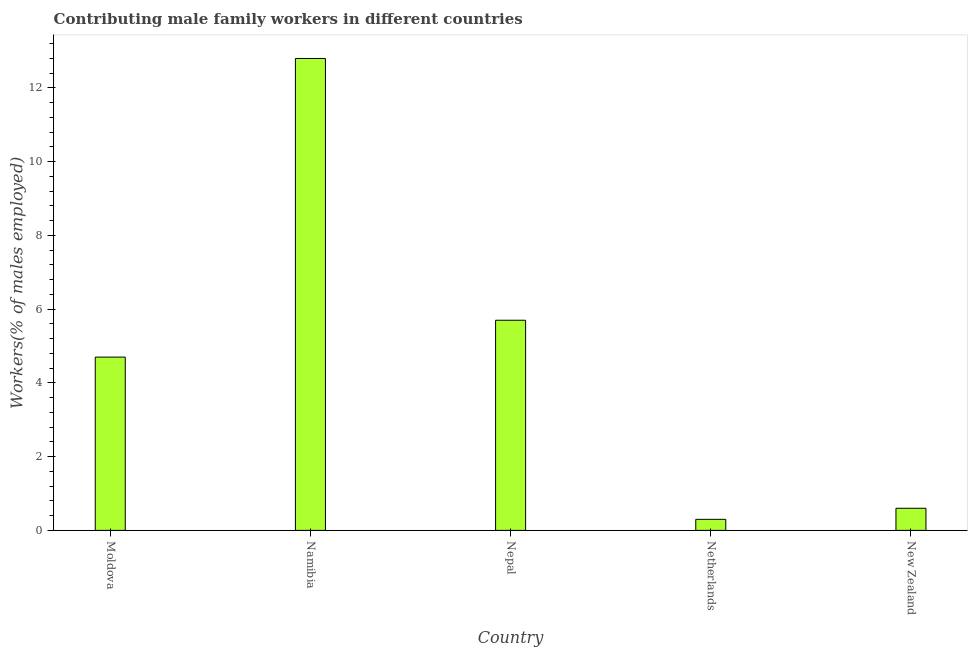Does the graph contain any zero values?
Ensure brevity in your answer.  No. What is the title of the graph?
Give a very brief answer. Contributing male family workers in different countries. What is the label or title of the Y-axis?
Keep it short and to the point. Workers(% of males employed). What is the contributing male family workers in Moldova?
Your answer should be very brief. 4.7. Across all countries, what is the maximum contributing male family workers?
Your answer should be compact. 12.8. Across all countries, what is the minimum contributing male family workers?
Give a very brief answer. 0.3. In which country was the contributing male family workers maximum?
Offer a terse response. Namibia. In which country was the contributing male family workers minimum?
Your answer should be very brief. Netherlands. What is the sum of the contributing male family workers?
Your response must be concise. 24.1. What is the difference between the contributing male family workers in Netherlands and New Zealand?
Provide a succinct answer. -0.3. What is the average contributing male family workers per country?
Keep it short and to the point. 4.82. What is the median contributing male family workers?
Ensure brevity in your answer.  4.7. In how many countries, is the contributing male family workers greater than 3.2 %?
Give a very brief answer. 3. Is the contributing male family workers in Nepal less than that in New Zealand?
Your response must be concise. No. What is the difference between the highest and the second highest contributing male family workers?
Make the answer very short. 7.1. Is the sum of the contributing male family workers in Moldova and New Zealand greater than the maximum contributing male family workers across all countries?
Ensure brevity in your answer.  No. What is the difference between the highest and the lowest contributing male family workers?
Provide a short and direct response. 12.5. In how many countries, is the contributing male family workers greater than the average contributing male family workers taken over all countries?
Offer a terse response. 2. How many bars are there?
Make the answer very short. 5. Are all the bars in the graph horizontal?
Keep it short and to the point. No. How many countries are there in the graph?
Your answer should be compact. 5. What is the difference between two consecutive major ticks on the Y-axis?
Offer a terse response. 2. What is the Workers(% of males employed) in Moldova?
Ensure brevity in your answer.  4.7. What is the Workers(% of males employed) of Namibia?
Offer a terse response. 12.8. What is the Workers(% of males employed) of Nepal?
Keep it short and to the point. 5.7. What is the Workers(% of males employed) of Netherlands?
Make the answer very short. 0.3. What is the Workers(% of males employed) of New Zealand?
Give a very brief answer. 0.6. What is the difference between the Workers(% of males employed) in Moldova and Netherlands?
Your answer should be compact. 4.4. What is the difference between the Workers(% of males employed) in Namibia and Netherlands?
Offer a very short reply. 12.5. What is the difference between the Workers(% of males employed) in Nepal and Netherlands?
Your response must be concise. 5.4. What is the ratio of the Workers(% of males employed) in Moldova to that in Namibia?
Ensure brevity in your answer.  0.37. What is the ratio of the Workers(% of males employed) in Moldova to that in Nepal?
Your response must be concise. 0.82. What is the ratio of the Workers(% of males employed) in Moldova to that in Netherlands?
Your response must be concise. 15.67. What is the ratio of the Workers(% of males employed) in Moldova to that in New Zealand?
Ensure brevity in your answer.  7.83. What is the ratio of the Workers(% of males employed) in Namibia to that in Nepal?
Ensure brevity in your answer.  2.25. What is the ratio of the Workers(% of males employed) in Namibia to that in Netherlands?
Your response must be concise. 42.67. What is the ratio of the Workers(% of males employed) in Namibia to that in New Zealand?
Offer a very short reply. 21.33. What is the ratio of the Workers(% of males employed) in Nepal to that in Netherlands?
Your answer should be compact. 19. What is the ratio of the Workers(% of males employed) in Nepal to that in New Zealand?
Provide a succinct answer. 9.5. What is the ratio of the Workers(% of males employed) in Netherlands to that in New Zealand?
Offer a terse response. 0.5. 